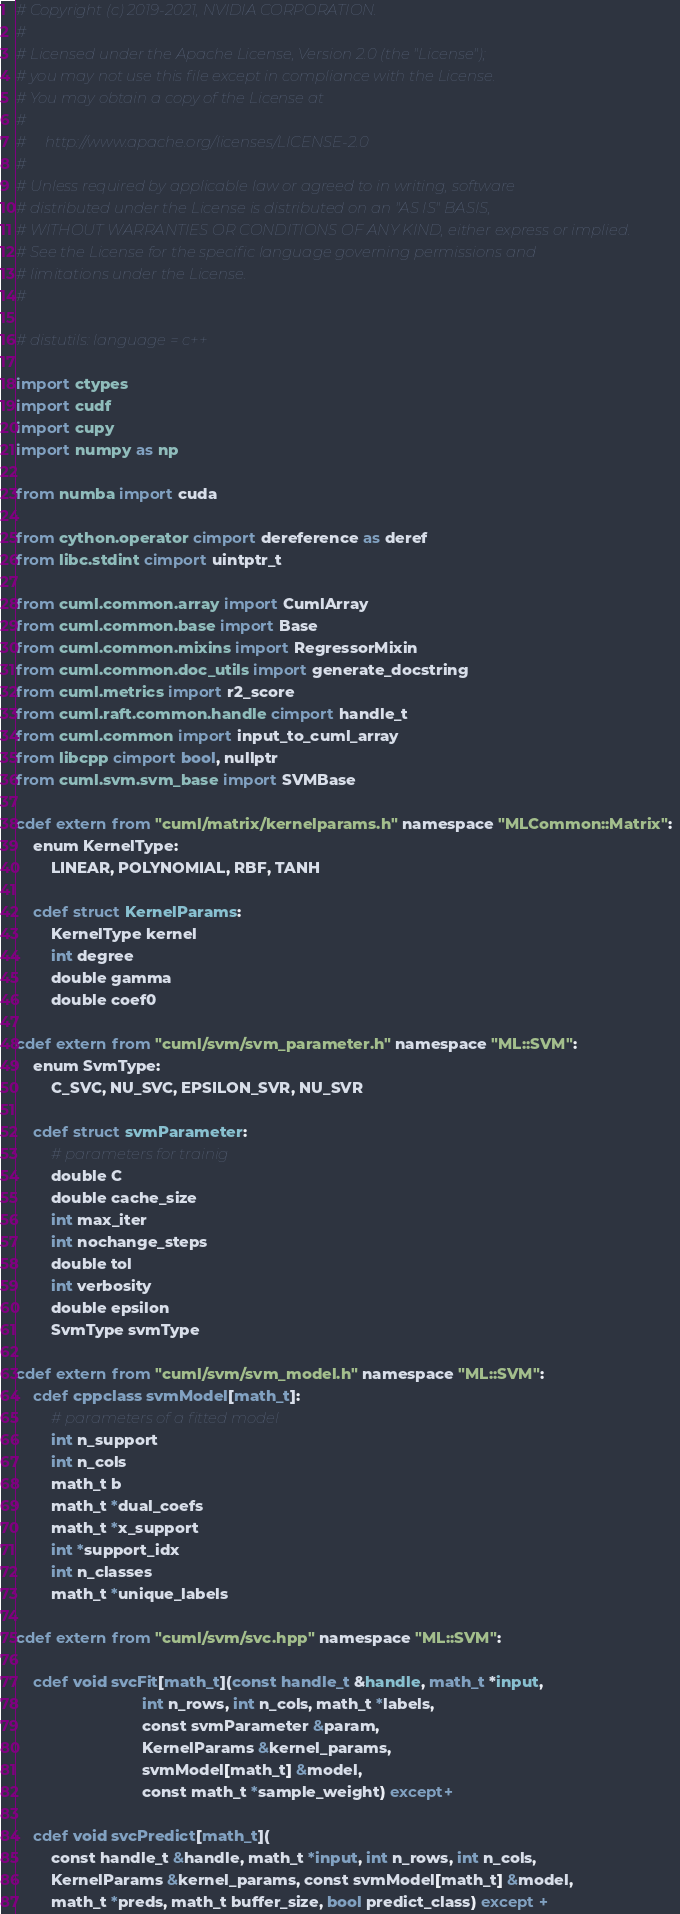<code> <loc_0><loc_0><loc_500><loc_500><_Cython_># Copyright (c) 2019-2021, NVIDIA CORPORATION.
#
# Licensed under the Apache License, Version 2.0 (the "License");
# you may not use this file except in compliance with the License.
# You may obtain a copy of the License at
#
#     http://www.apache.org/licenses/LICENSE-2.0
#
# Unless required by applicable law or agreed to in writing, software
# distributed under the License is distributed on an "AS IS" BASIS,
# WITHOUT WARRANTIES OR CONDITIONS OF ANY KIND, either express or implied.
# See the License for the specific language governing permissions and
# limitations under the License.
#

# distutils: language = c++

import ctypes
import cudf
import cupy
import numpy as np

from numba import cuda

from cython.operator cimport dereference as deref
from libc.stdint cimport uintptr_t

from cuml.common.array import CumlArray
from cuml.common.base import Base
from cuml.common.mixins import RegressorMixin
from cuml.common.doc_utils import generate_docstring
from cuml.metrics import r2_score
from cuml.raft.common.handle cimport handle_t
from cuml.common import input_to_cuml_array
from libcpp cimport bool, nullptr
from cuml.svm.svm_base import SVMBase

cdef extern from "cuml/matrix/kernelparams.h" namespace "MLCommon::Matrix":
    enum KernelType:
        LINEAR, POLYNOMIAL, RBF, TANH

    cdef struct KernelParams:
        KernelType kernel
        int degree
        double gamma
        double coef0

cdef extern from "cuml/svm/svm_parameter.h" namespace "ML::SVM":
    enum SvmType:
        C_SVC, NU_SVC, EPSILON_SVR, NU_SVR

    cdef struct svmParameter:
        # parameters for trainig
        double C
        double cache_size
        int max_iter
        int nochange_steps
        double tol
        int verbosity
        double epsilon
        SvmType svmType

cdef extern from "cuml/svm/svm_model.h" namespace "ML::SVM":
    cdef cppclass svmModel[math_t]:
        # parameters of a fitted model
        int n_support
        int n_cols
        math_t b
        math_t *dual_coefs
        math_t *x_support
        int *support_idx
        int n_classes
        math_t *unique_labels

cdef extern from "cuml/svm/svc.hpp" namespace "ML::SVM":

    cdef void svcFit[math_t](const handle_t &handle, math_t *input,
                             int n_rows, int n_cols, math_t *labels,
                             const svmParameter &param,
                             KernelParams &kernel_params,
                             svmModel[math_t] &model,
                             const math_t *sample_weight) except+

    cdef void svcPredict[math_t](
        const handle_t &handle, math_t *input, int n_rows, int n_cols,
        KernelParams &kernel_params, const svmModel[math_t] &model,
        math_t *preds, math_t buffer_size, bool predict_class) except +
</code> 